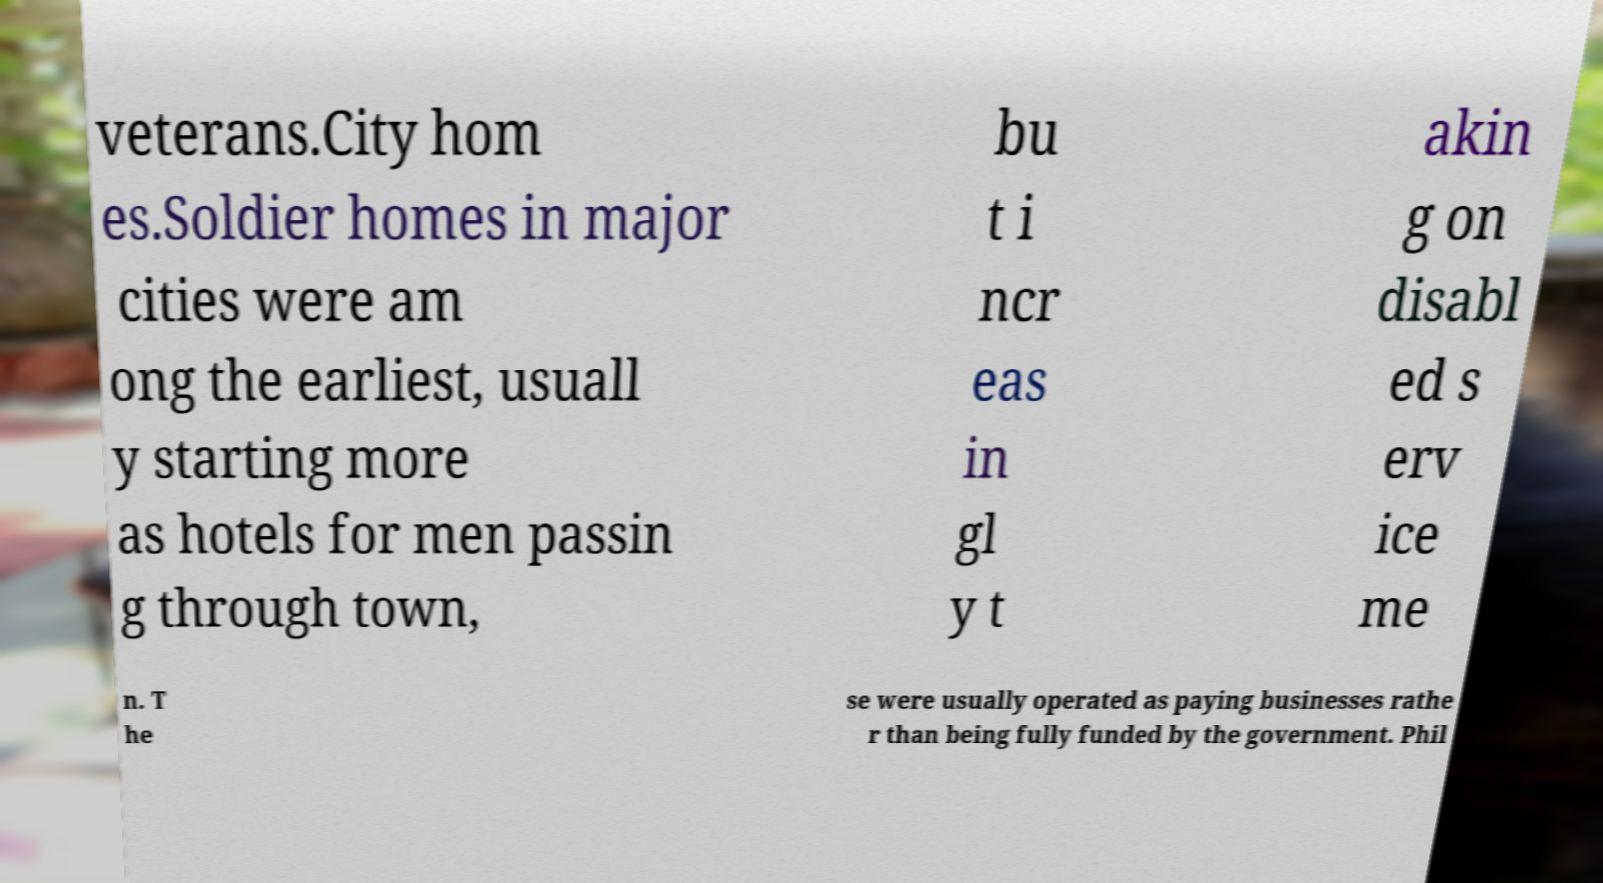Could you extract and type out the text from this image? veterans.City hom es.Soldier homes in major cities were am ong the earliest, usuall y starting more as hotels for men passin g through town, bu t i ncr eas in gl y t akin g on disabl ed s erv ice me n. T he se were usually operated as paying businesses rathe r than being fully funded by the government. Phil 